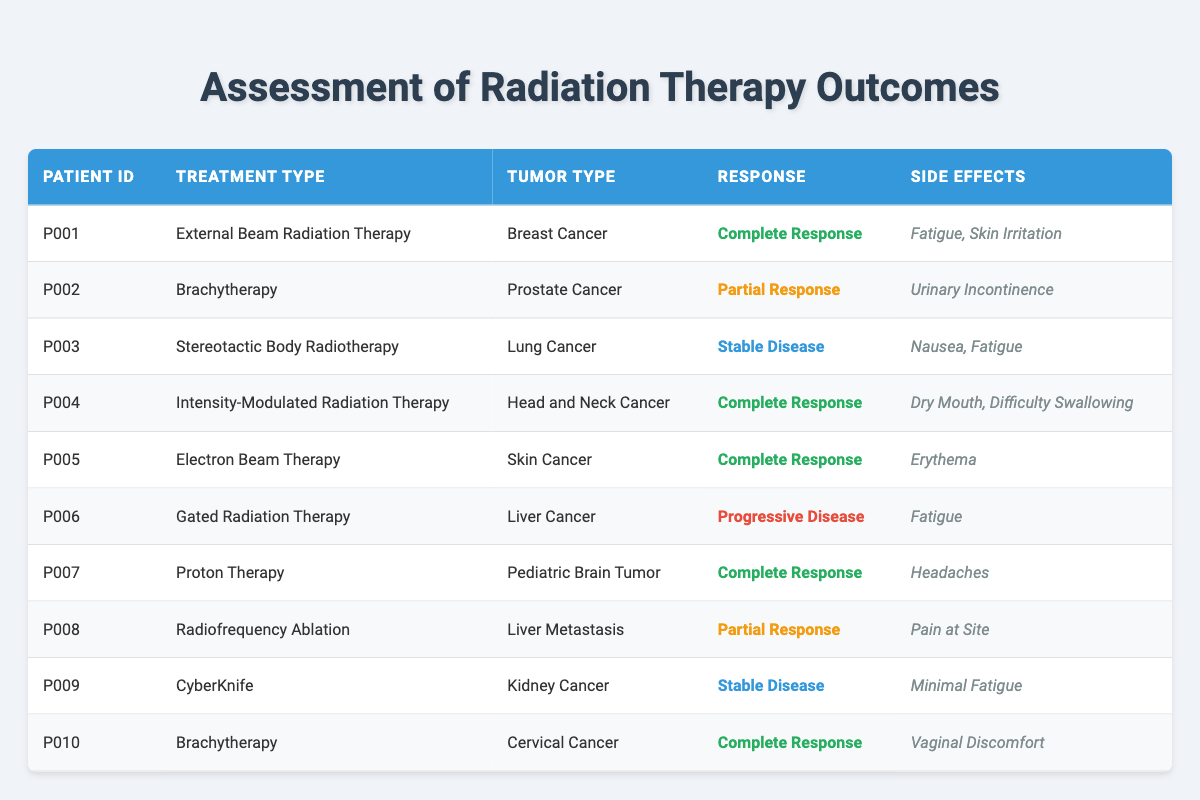What treatment types resulted in a complete response? By looking through the table, I can see that the following treatment types have resulted in a complete response: External Beam Radiation Therapy, Intensity-Modulated Radiation Therapy, Electron Beam Therapy, Proton Therapy, and Brachytherapy (for Cervical Cancer). These treatments correspond to patient IDs P001, P004, P005, P007, and P010.
Answer: External Beam Radiation Therapy, Intensity-Modulated Radiation Therapy, Electron Beam Therapy, Proton Therapy, Brachytherapy How many patients received brachytherapy? From the table, I identify two patients who received brachytherapy: P002 (Prostate Cancer) and P010 (Cervical Cancer). Counting these gives a total of 2 patients.
Answer: 2 What side effects were reported for patients with a stable disease response? The table shows that there are two patients with a stable disease response: P003 (Stereotactic Body Radiotherapy) reported Nausea and Fatigue, while P009 (CyberKnife) reported Minimal Fatigue. So, combining those side effects results in Nausea, Fatigue, and Minimal Fatigue being reported.
Answer: Nausea, Fatigue, Minimal Fatigue Did any patients experience progressive disease after treatment? Looking through the table, patient P006 received Gated Radiation Therapy and experienced progressive disease. I conclude that yes, there is a patient who experienced progressive disease.
Answer: Yes What is the total number of side effects reported among patients treated with external beam radiation therapy and brachytherapy? First, I check the side effects reported for each treatment type. For external beam radiation therapy (P001), the side effects are Fatigue and Skin Irritation (2 side effects). For brachytherapy (P002 has Urinary Incontinence and P010 has Vaginal Discomfort - a total of 4 side effects). So adding these gives a total of 2 (from P001) + 2 (from P002) + 1 (from P010) = 5 side effects.
Answer: 5 What percentage of patients received a treatment leading to a complete response? There are 10 total patients, and from the earlier established data, 5 of them experienced a complete response. To calculate the percentage, the formula is (5 complete responses / 10 total patients) * 100 = 50%. Therefore, the conclusion is that 50% of the patients received treatment leading to a complete response.
Answer: 50% 